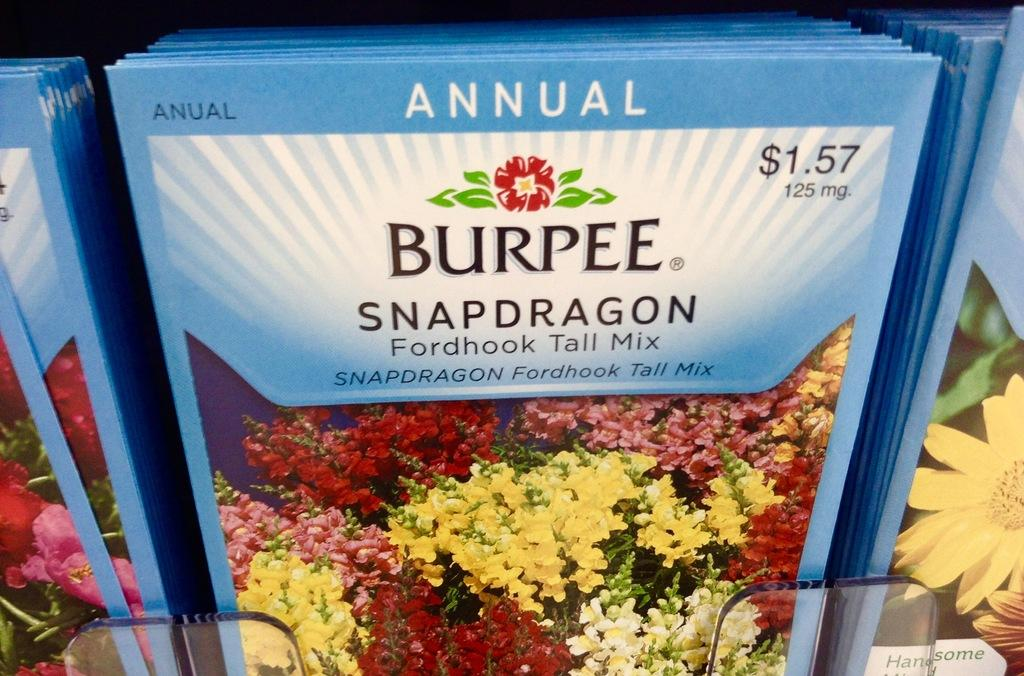What is located in the center of the image? There are packets in the center of the image. What can be found on the packets? There is text and flowers on the packets. What type of committee is depicted on the packets in the image? There is no committee depicted on the packets in the image; the packets feature text and flowers. What color is the gold balloon on the packets in the image? There is no gold balloon present on the packets in the image; the packets have text and flowers. 